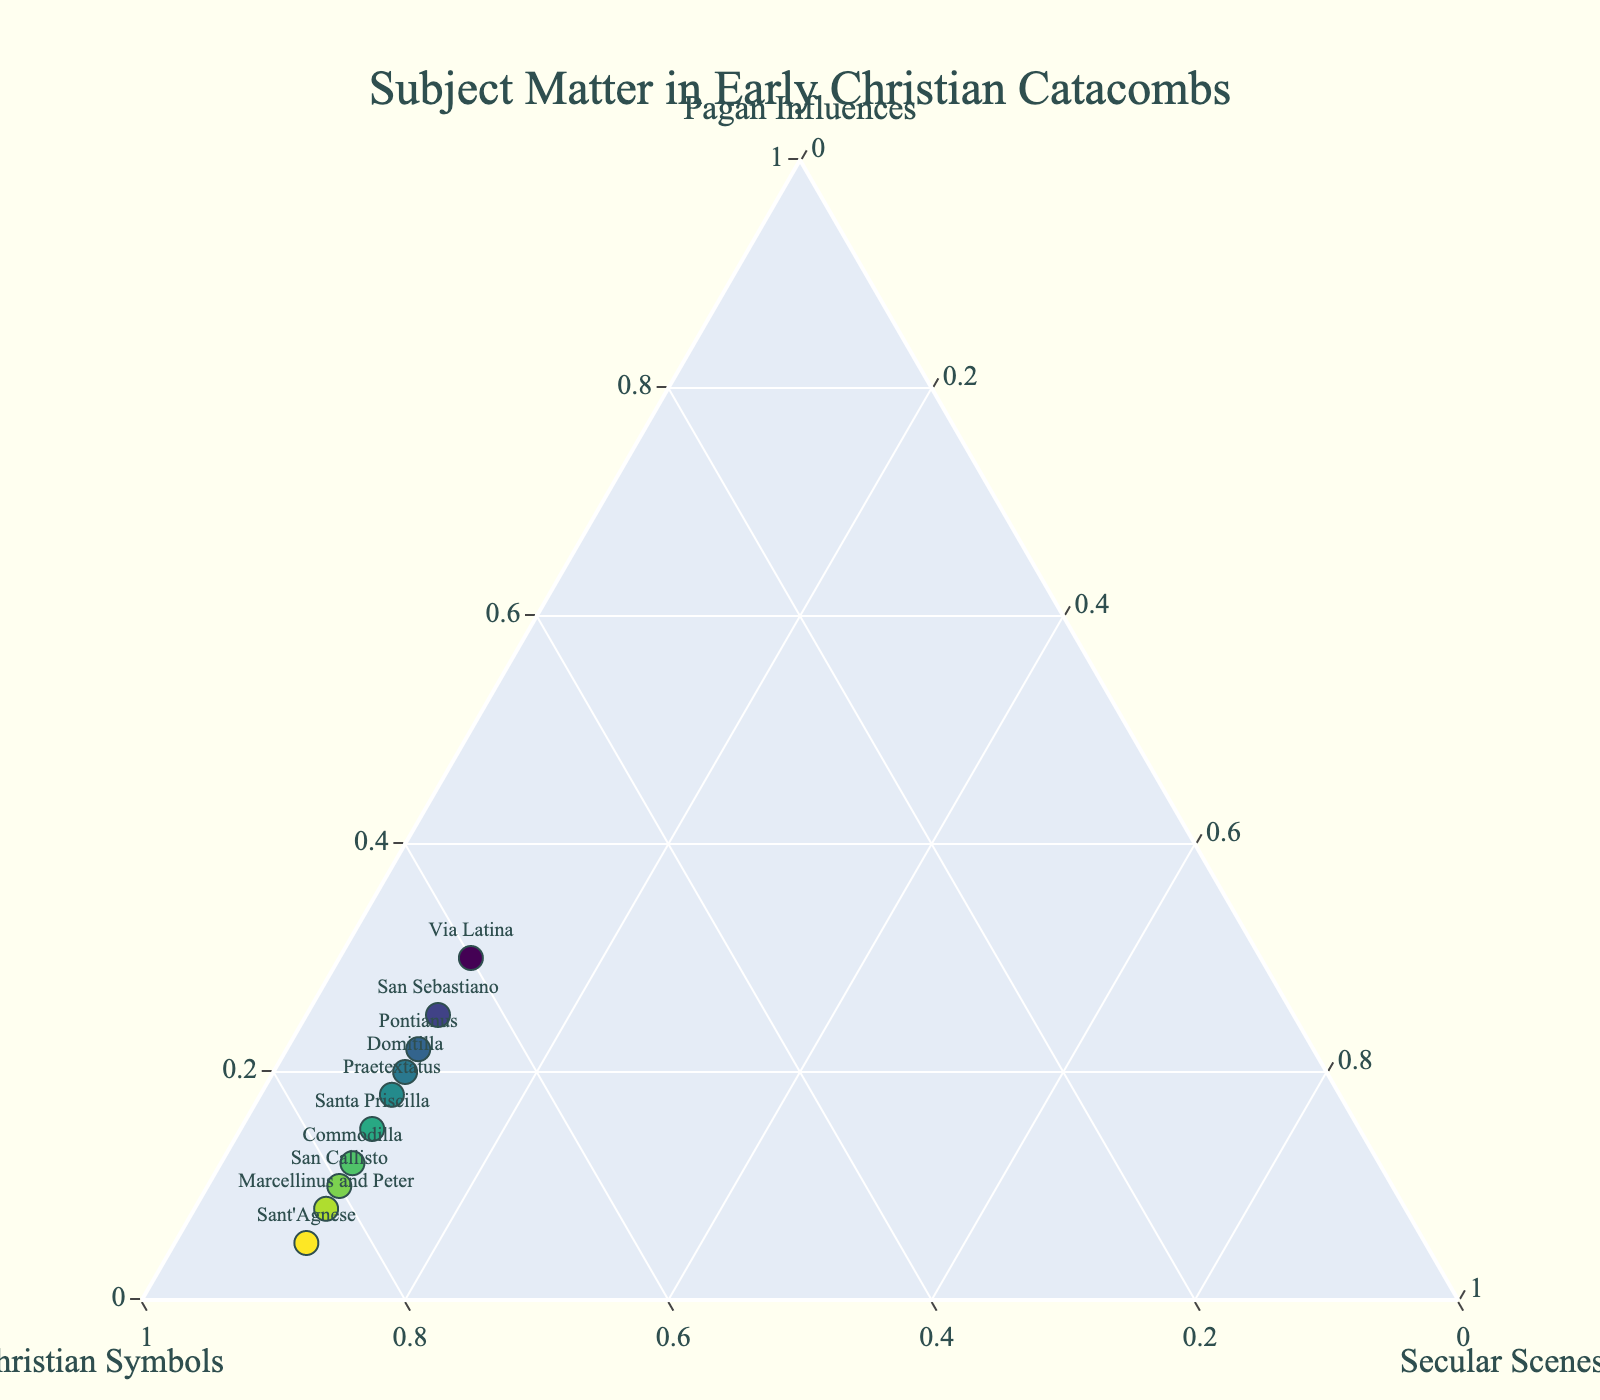What is the title of the plot? The title of the plot is written at the top and serves as a summary of what the plot represents.
Answer: Subject Matter in Early Christian Catacombs How many catacombs are represented in the plot? The plot shows markers for each catacomb, and counting these markers provides the answer.
Answer: 10 Which catacomb has the highest proportion of Christian symbols? The color of the markers indicates the proportion of Christian symbols, with darker colors representing higher values. Sant'Agnese has the darkest marker.
Answer: Sant'Agnese Which two catacombs have the smallest contribution from secular scenes? All catacombs have equal markers along the secular scenes axis. The equal distance from the origin along this axis shows that each has 10% for secular scenes.
Answer: All catacombs Which catacomb has the smallest contribution from pagan influences? By looking at the distribution of markers along the Pagan Influences axis and finding the one closest to the origin, we determine the one with the smallest contribution. Sant'Agnese is closest to the origin.
Answer: Sant'Agnese Among Santa Priscilla and Via Latina, which catacomb has a higher proportion of pagan influences? By inspecting the markers' positions along the Pagan Influences axis, we see that Via Latina is further along, indicating a higher proportion.
Answer: Via Latina What is the average percentage of Christian symbols across all catacombs? The sum of all Christian symbols percentages is (75+80+70+65+85+60+78+72+82+68) = 735. Dividing by the number of catacombs, 10, gives 735/10.
Answer: 73.5% Which catacomb sits closest to the centroid (mean) of the dataset in terms of subject matter proportions? Looking for the marker that appears visually closest to the center of the plot. San Callisto appears to be centrally located, suggesting balanced subject proportions.
Answer: San Callisto Comparing Santa Priscilla and Domitilla, which catacomb has a lower proportion of Christian symbols? Examining the markers' positions along the Christian Symbols axis reveals that Domitilla is closer to the origin than Santa Priscilla along this axis.
Answer: Domitilla 